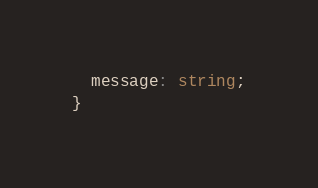Convert code to text. <code><loc_0><loc_0><loc_500><loc_500><_TypeScript_>  message: string;
}
</code> 